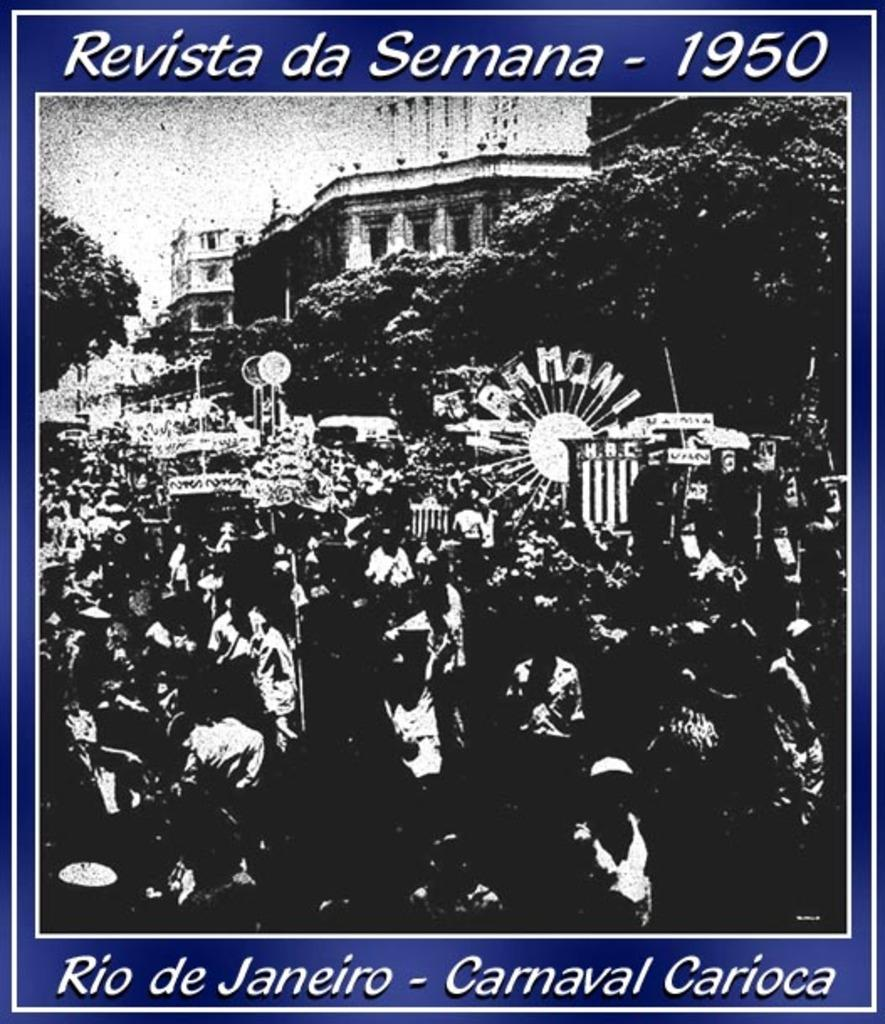What is depicted in the image? There is a poster in the image. What can be seen on the poster? There are people standing in the poster, as well as trees and buildings. What type of fiction is being copied in the image? There is no reference to copying or fiction in the image; it features a poster with people, trees, and buildings. 